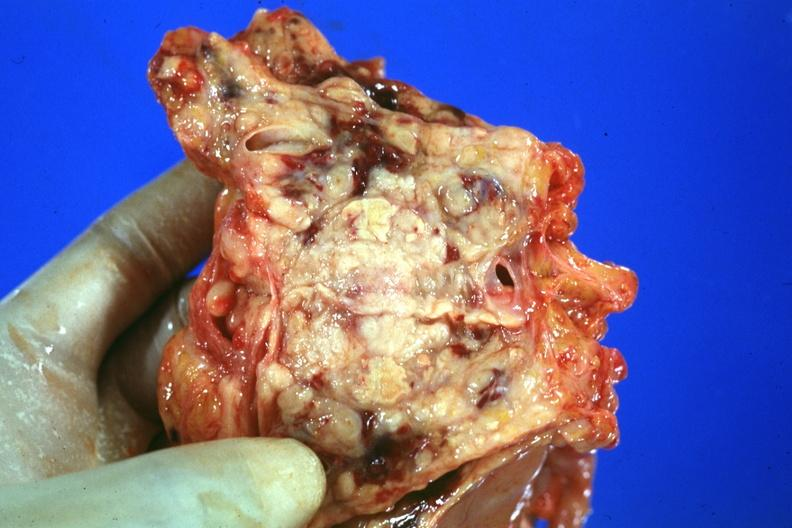s prostate cut open showing neoplasm quite good?
Answer the question using a single word or phrase. Yes 